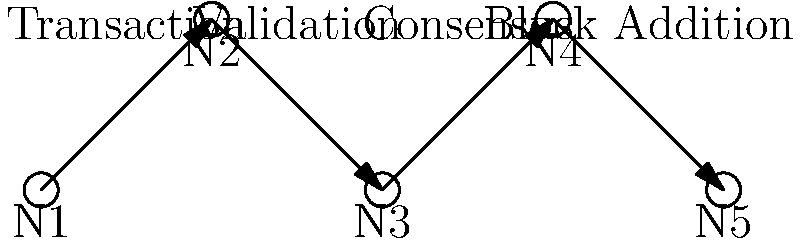In the blockchain transaction flow visualization above, which node represents the crucial step where network participants agree on the validity of a transaction before it's added to the blockchain? To answer this question, let's analyze the blockchain transaction flow step-by-step:

1. Node 1 (N1): This is typically the initiation of a transaction.
2. Node 2 (N2): This represents the validation of the transaction, where the network checks if the transaction is properly formatted and if the sender has sufficient funds.
3. Node 3 (N3): This node is labeled "Consensus" and represents the crucial step where network participants agree on the validity of a transaction.
4. Node 4 (N4): This represents the addition of the validated and agreed-upon transaction to a new block.
5. Node 5 (N5): This likely represents the finalized state where the new block is added to the blockchain.

The consensus step (N3) is crucial because it ensures that all nodes in the network agree on the state of the blockchain, preventing double-spending and maintaining the integrity of the system. This is typically achieved through consensus algorithms like Proof of Work (PoW) or Proof of Stake (PoS).

Therefore, Node 3 (N3) represents the crucial consensus step in this blockchain transaction flow.
Answer: N3 